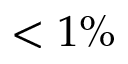<formula> <loc_0><loc_0><loc_500><loc_500>< 1 \%</formula> 